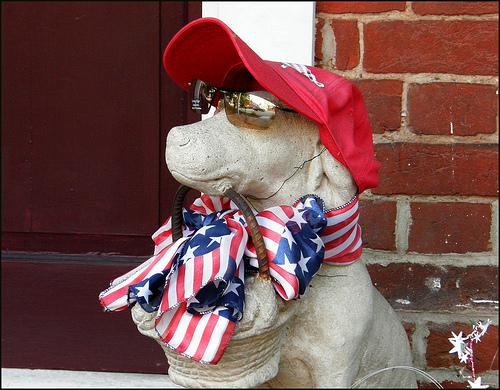Question: who is wearing sunglasses?
Choices:
A. Cat.
B. Horse.
C. Dog.
D. Bear.
Answer with the letter. Answer: C Question: where is the ribbon?
Choices:
A. On fence.
B. Around neck.
C. In her hair.
D. On the dress.
Answer with the letter. Answer: B Question: who is this a photo of?
Choices:
A. Stone dog.
B. Ceramic cat.
C. Plush lion.
D. Purple bear.
Answer with the letter. Answer: A Question: what is on his head?
Choices:
A. Sunglasses.
B. Wig.
C. Hat.
D. Ponytail.
Answer with the letter. Answer: C Question: why is the dog dressed?
Choices:
A. Party.
B. Halloween.
C. Decoration.
D. Stay warm.
Answer with the letter. Answer: C 